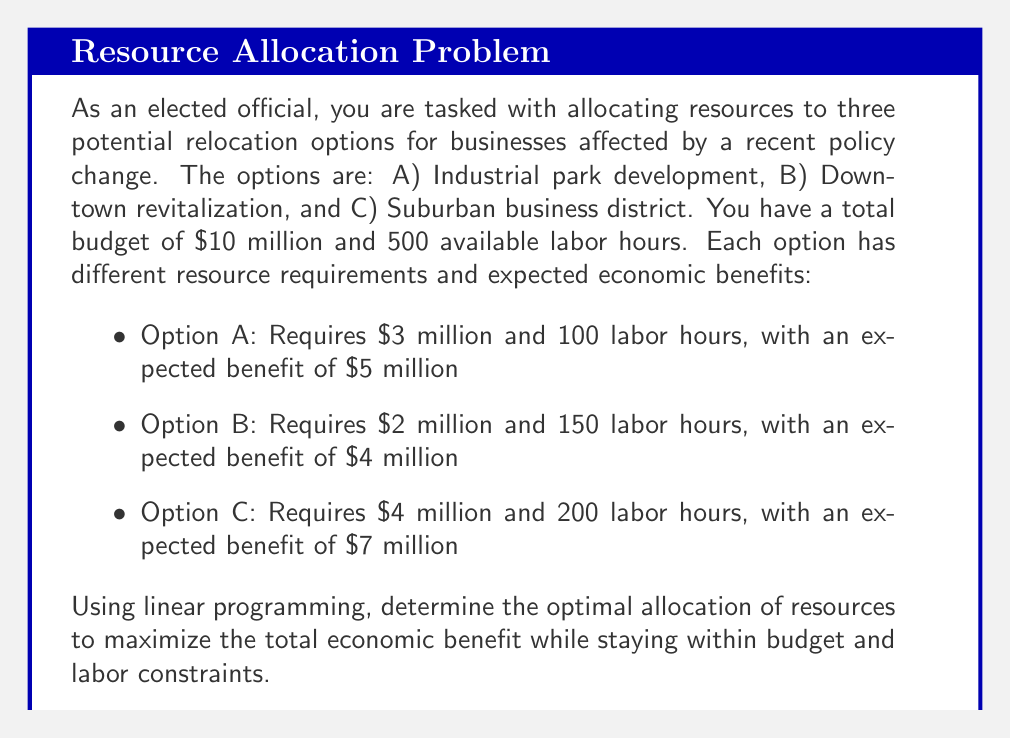Help me with this question. To solve this problem using linear programming, we need to follow these steps:

1. Define the decision variables:
Let $x_A$, $x_B$, and $x_C$ represent the number of units of each option to implement.

2. Set up the objective function:
Maximize $Z = 5x_A + 4x_B + 7x_C$

3. Define the constraints:
Budget constraint: $3x_A + 2x_B + 4x_C \leq 10$
Labor constraint: $100x_A + 150x_B + 200x_C \leq 500$
Non-negativity constraints: $x_A, x_B, x_C \geq 0$

4. Solve the linear programming problem:
We can use the simplex method or a graphical approach. In this case, we'll use the graphical method as we have only two binding constraints.

5. Plot the constraints:
Budget constraint: $3x_A + 2x_B + 4x_C = 10$
Labor constraint: $100x_A + 150x_B + 200x_C = 500$

6. Find the corner points:
(0, 0, 2.5), (0, 5, 0), (3.33, 0, 0), (0, 3.33, 0.83), (2.5, 0, 1.25)

7. Evaluate the objective function at each corner point:
(0, 0, 2.5): $Z = 17.5$ million
(0, 5, 0): $Z = 20$ million
(3.33, 0, 0): $Z = 16.65$ million
(0, 3.33, 0.83): $Z = 19.15$ million
(2.5, 0, 1.25): $Z = 21.25$ million

The maximum value of the objective function occurs at the point (2.5, 0, 1.25).
Answer: The optimal allocation of resources is:
Option A (Industrial park development): 2.5 units
Option B (Downtown revitalization): 0 units
Option C (Suburban business district): 1.25 units

This allocation will result in a maximum total economic benefit of $21.25 million. 